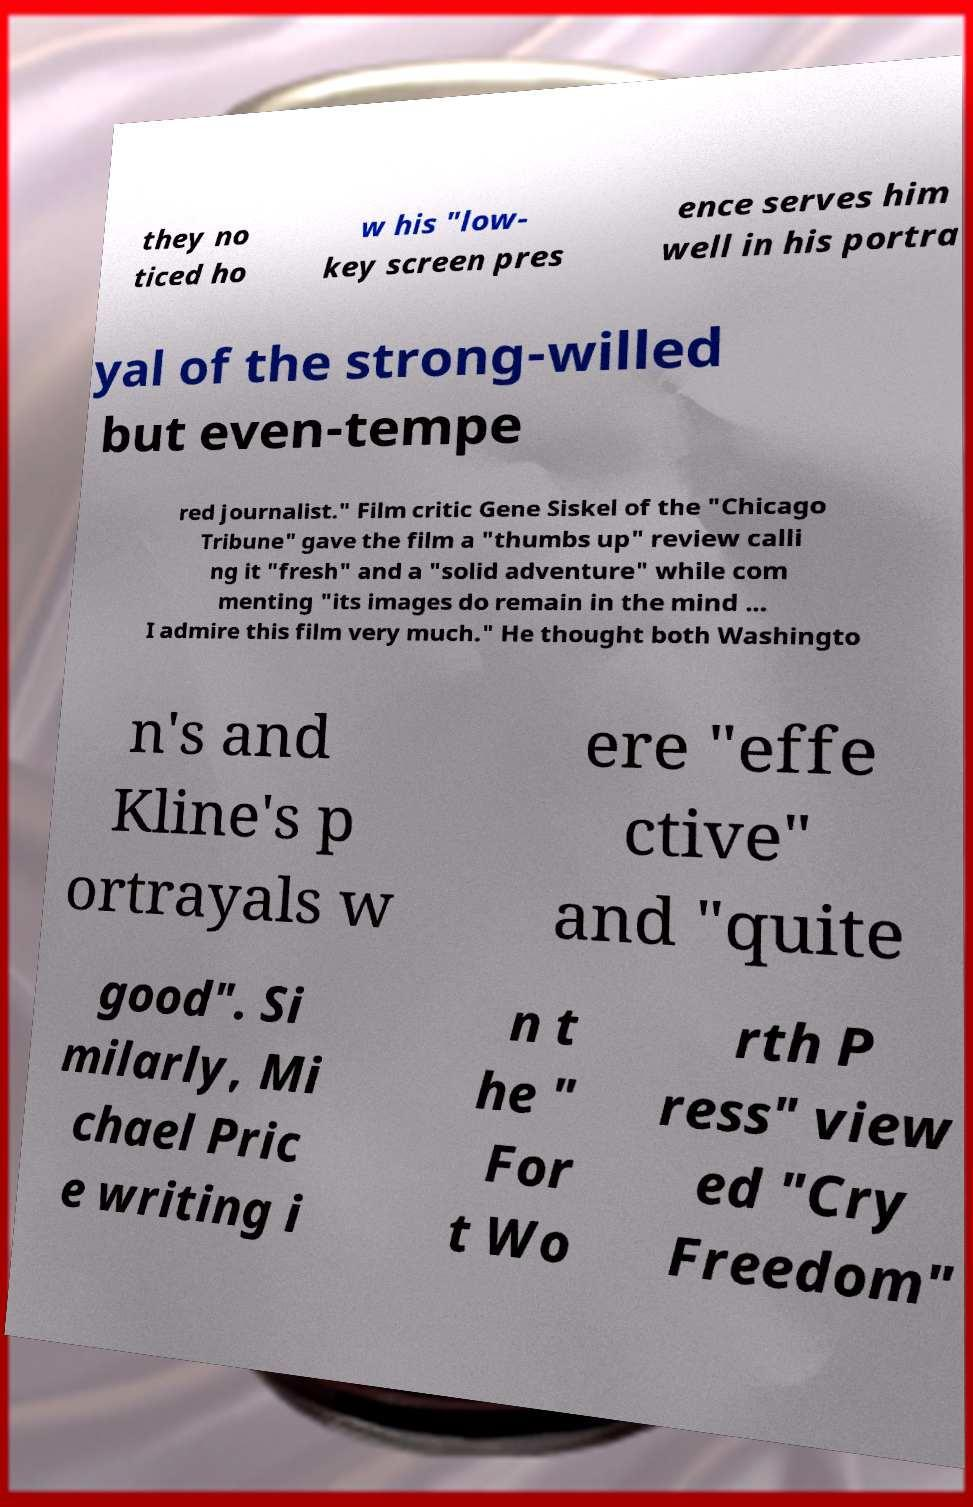Can you accurately transcribe the text from the provided image for me? they no ticed ho w his "low- key screen pres ence serves him well in his portra yal of the strong-willed but even-tempe red journalist." Film critic Gene Siskel of the "Chicago Tribune" gave the film a "thumbs up" review calli ng it "fresh" and a "solid adventure" while com menting "its images do remain in the mind ... I admire this film very much." He thought both Washingto n's and Kline's p ortrayals w ere "effe ctive" and "quite good". Si milarly, Mi chael Pric e writing i n t he " For t Wo rth P ress" view ed "Cry Freedom" 